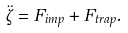<formula> <loc_0><loc_0><loc_500><loc_500>\ddot { \zeta } = F _ { i m p } + F _ { t r a p } .</formula> 